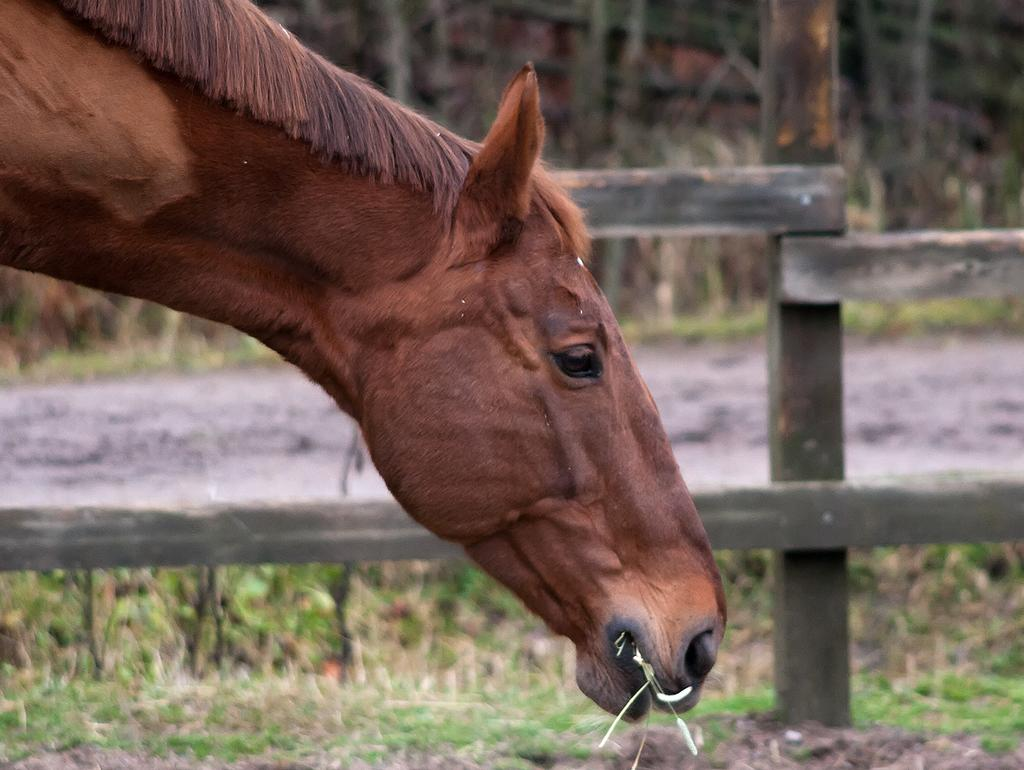What type of animal is in the foreground of the image? There is a brown horse in the foreground of the image. What can be seen in the background of the image? There is grass and wooden fencing in the background of the image. What year is the horse's treatment scheduled for in the image? There is no information about the horse's treatment or any scheduling in the image. 